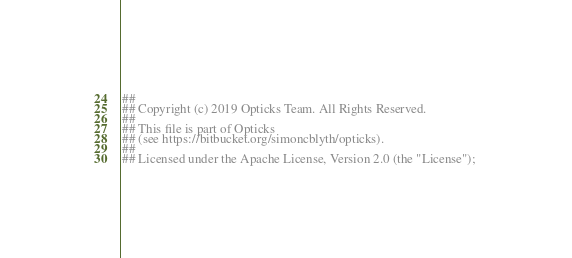Convert code to text. <code><loc_0><loc_0><loc_500><loc_500><_Bash_>##
## Copyright (c) 2019 Opticks Team. All Rights Reserved.
##
## This file is part of Opticks
## (see https://bitbucket.org/simoncblyth/opticks).
##
## Licensed under the Apache License, Version 2.0 (the "License"); </code> 